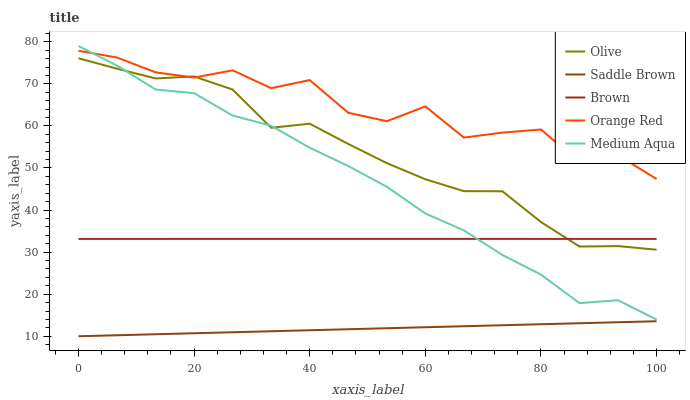Does Saddle Brown have the minimum area under the curve?
Answer yes or no. Yes. Does Orange Red have the maximum area under the curve?
Answer yes or no. Yes. Does Brown have the minimum area under the curve?
Answer yes or no. No. Does Brown have the maximum area under the curve?
Answer yes or no. No. Is Saddle Brown the smoothest?
Answer yes or no. Yes. Is Orange Red the roughest?
Answer yes or no. Yes. Is Brown the smoothest?
Answer yes or no. No. Is Brown the roughest?
Answer yes or no. No. Does Saddle Brown have the lowest value?
Answer yes or no. Yes. Does Brown have the lowest value?
Answer yes or no. No. Does Medium Aqua have the highest value?
Answer yes or no. Yes. Does Brown have the highest value?
Answer yes or no. No. Is Saddle Brown less than Olive?
Answer yes or no. Yes. Is Olive greater than Saddle Brown?
Answer yes or no. Yes. Does Medium Aqua intersect Orange Red?
Answer yes or no. Yes. Is Medium Aqua less than Orange Red?
Answer yes or no. No. Is Medium Aqua greater than Orange Red?
Answer yes or no. No. Does Saddle Brown intersect Olive?
Answer yes or no. No. 